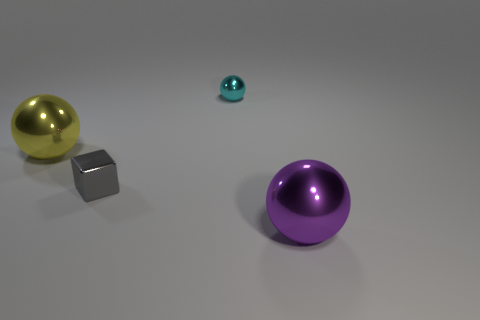Can you describe the arrangement of objects in terms of their proximity to one another? Certainly! In the image, you'll notice that the large purple ball is prominently placed in the foreground. The large gray cube and the gold-colored ball are arranged a little further away, creating a staggered triangular formation. The smaller teal ball is the farthest, creating a sense of depth in the image. 